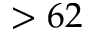<formula> <loc_0><loc_0><loc_500><loc_500>> 6 2</formula> 